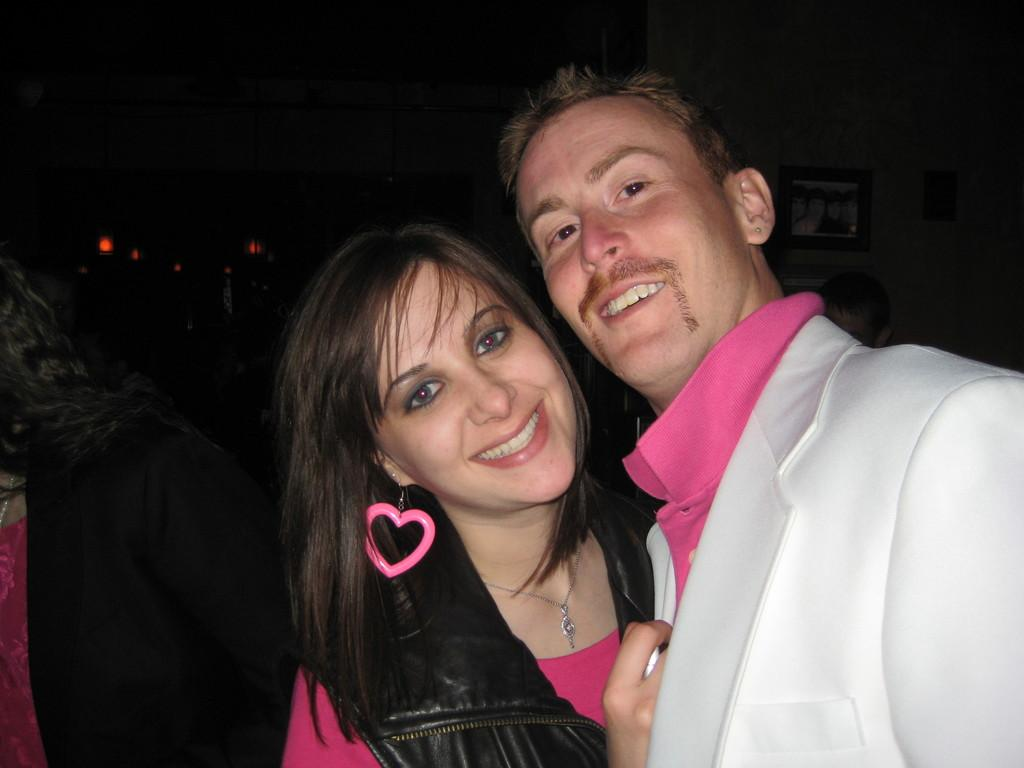Who is present in the image? There is a man and a woman in the image. What are the facial expressions of the people in the image? Both the man and the woman are smiling in the image. What type of drum can be seen in the background of the image? There is no drum present in the image. How many cacti are visible in the image? There are no cacti present in the image. 